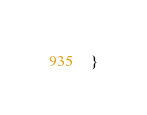<code> <loc_0><loc_0><loc_500><loc_500><_Go_>}
</code> 